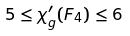Convert formula to latex. <formula><loc_0><loc_0><loc_500><loc_500>5 \leq \chi _ { g } ^ { \prime } ( F _ { 4 } ) \leq 6</formula> 